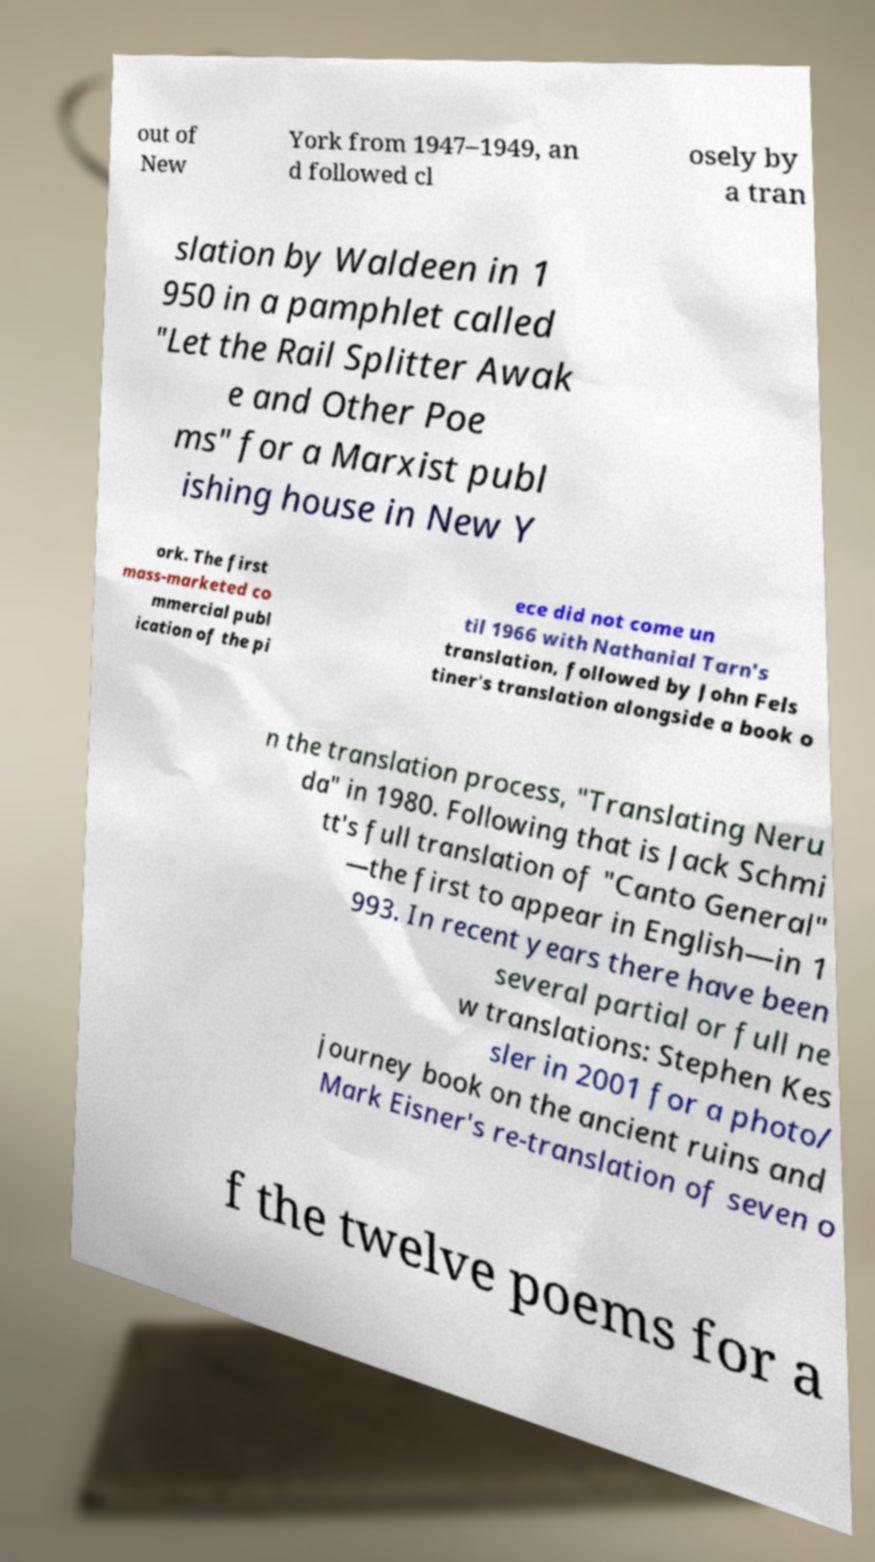For documentation purposes, I need the text within this image transcribed. Could you provide that? out of New York from 1947–1949, an d followed cl osely by a tran slation by Waldeen in 1 950 in a pamphlet called "Let the Rail Splitter Awak e and Other Poe ms" for a Marxist publ ishing house in New Y ork. The first mass-marketed co mmercial publ ication of the pi ece did not come un til 1966 with Nathanial Tarn's translation, followed by John Fels tiner's translation alongside a book o n the translation process, "Translating Neru da" in 1980. Following that is Jack Schmi tt's full translation of "Canto General" —the first to appear in English—in 1 993. In recent years there have been several partial or full ne w translations: Stephen Kes sler in 2001 for a photo/ journey book on the ancient ruins and Mark Eisner's re-translation of seven o f the twelve poems for a 